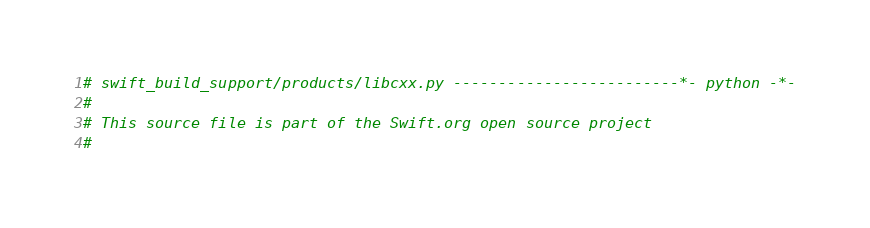Convert code to text. <code><loc_0><loc_0><loc_500><loc_500><_Python_># swift_build_support/products/libcxx.py -------------------------*- python -*-
#
# This source file is part of the Swift.org open source project
#</code> 